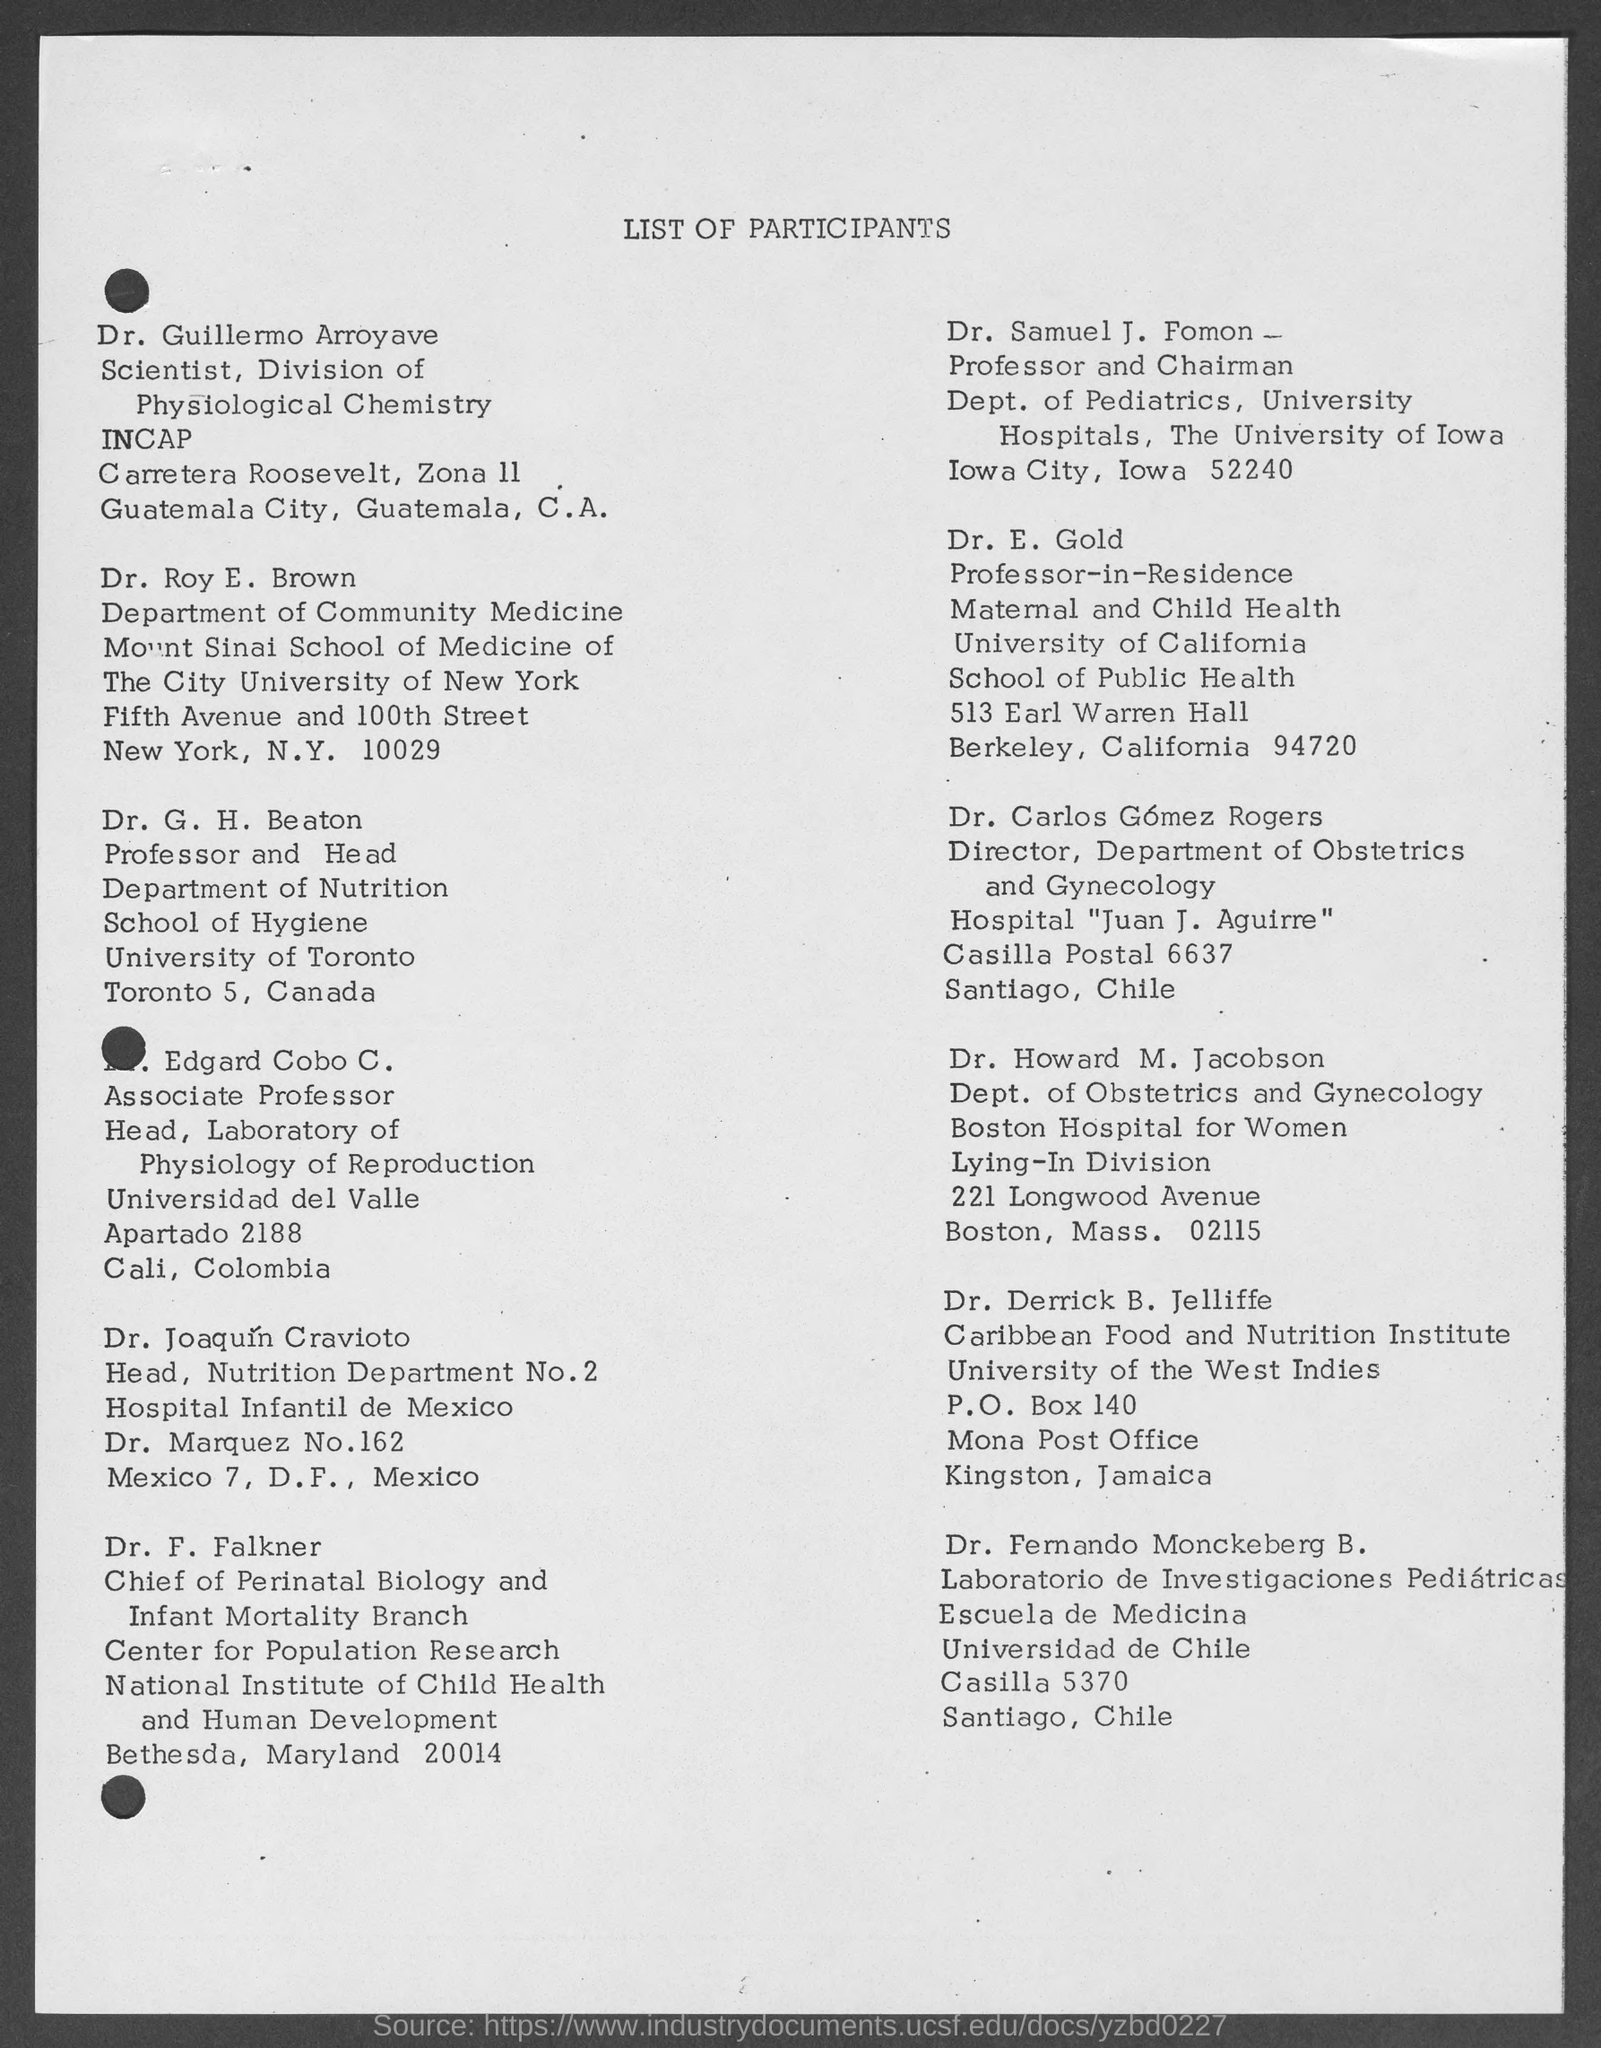What is the main title of this document?
Provide a short and direct response. LIST OF PARTICIPANTS. In which University, Dr. Derrick B. Jelliffe works?
Give a very brief answer. University of the West Indies. 